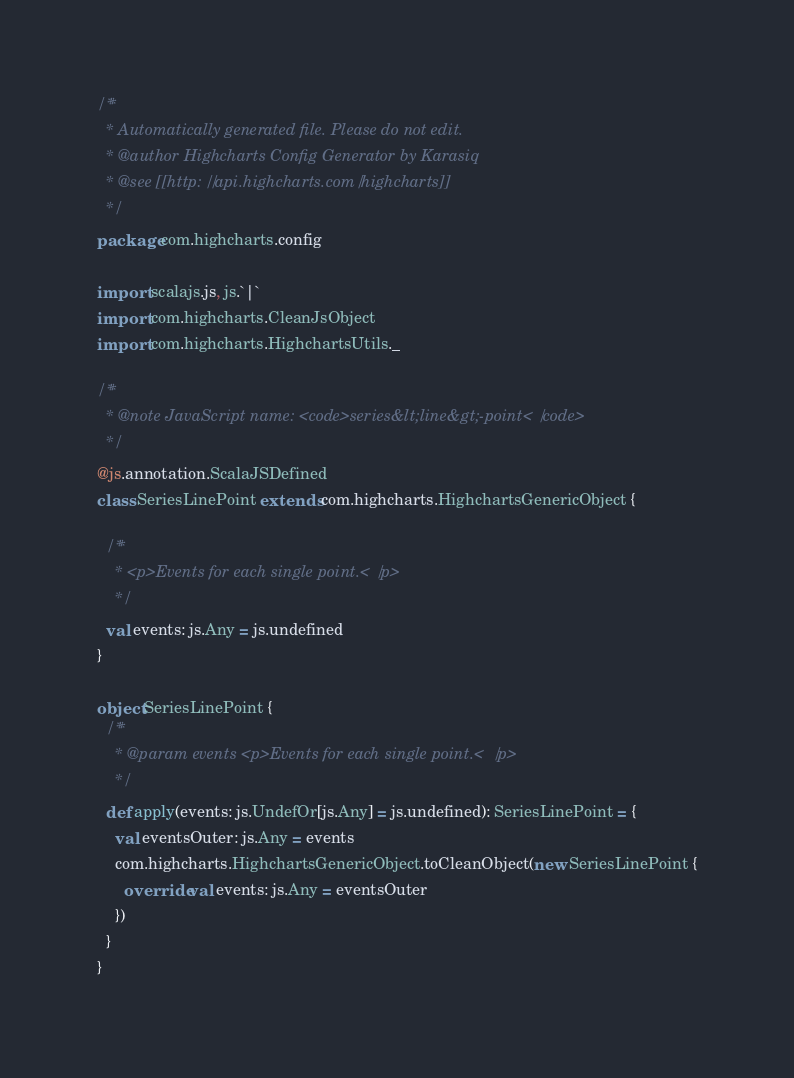Convert code to text. <code><loc_0><loc_0><loc_500><loc_500><_Scala_>/**
  * Automatically generated file. Please do not edit.
  * @author Highcharts Config Generator by Karasiq
  * @see [[http://api.highcharts.com/highcharts]]
  */
package com.highcharts.config

import scalajs.js, js.`|`
import com.highcharts.CleanJsObject
import com.highcharts.HighchartsUtils._

/**
  * @note JavaScript name: <code>series&lt;line&gt;-point</code>
  */
@js.annotation.ScalaJSDefined
class SeriesLinePoint extends com.highcharts.HighchartsGenericObject {

  /**
    * <p>Events for each single point.</p>
    */
  val events: js.Any = js.undefined
}

object SeriesLinePoint {
  /**
    * @param events <p>Events for each single point.</p>
    */
  def apply(events: js.UndefOr[js.Any] = js.undefined): SeriesLinePoint = {
    val eventsOuter: js.Any = events
    com.highcharts.HighchartsGenericObject.toCleanObject(new SeriesLinePoint {
      override val events: js.Any = eventsOuter
    })
  }
}
</code> 